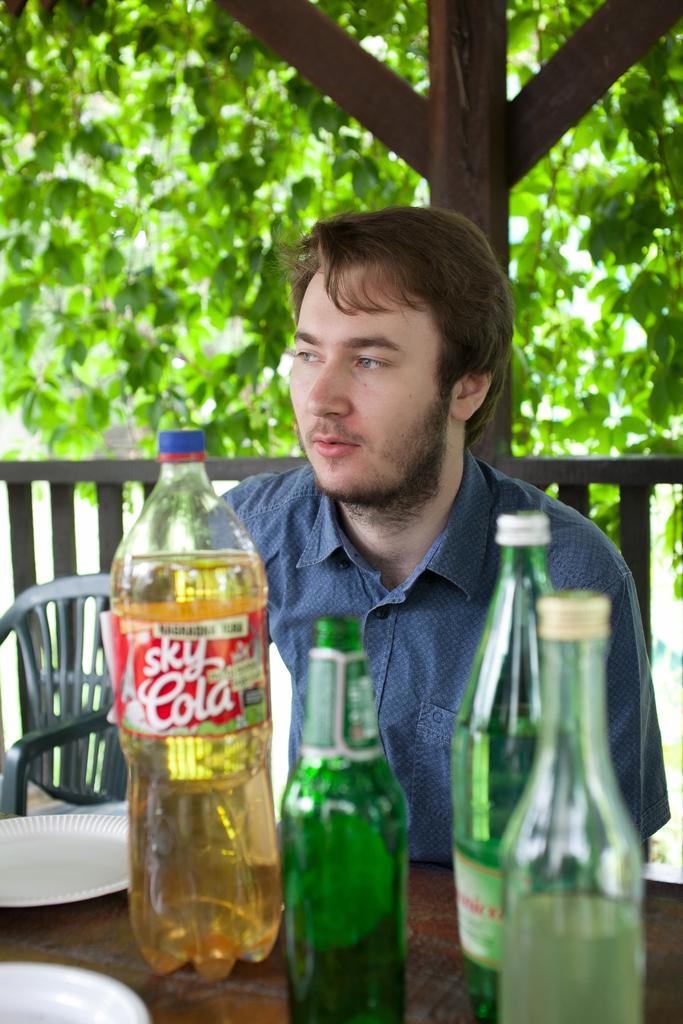What is the name of the cola drink?
Make the answer very short. Sky cola. 